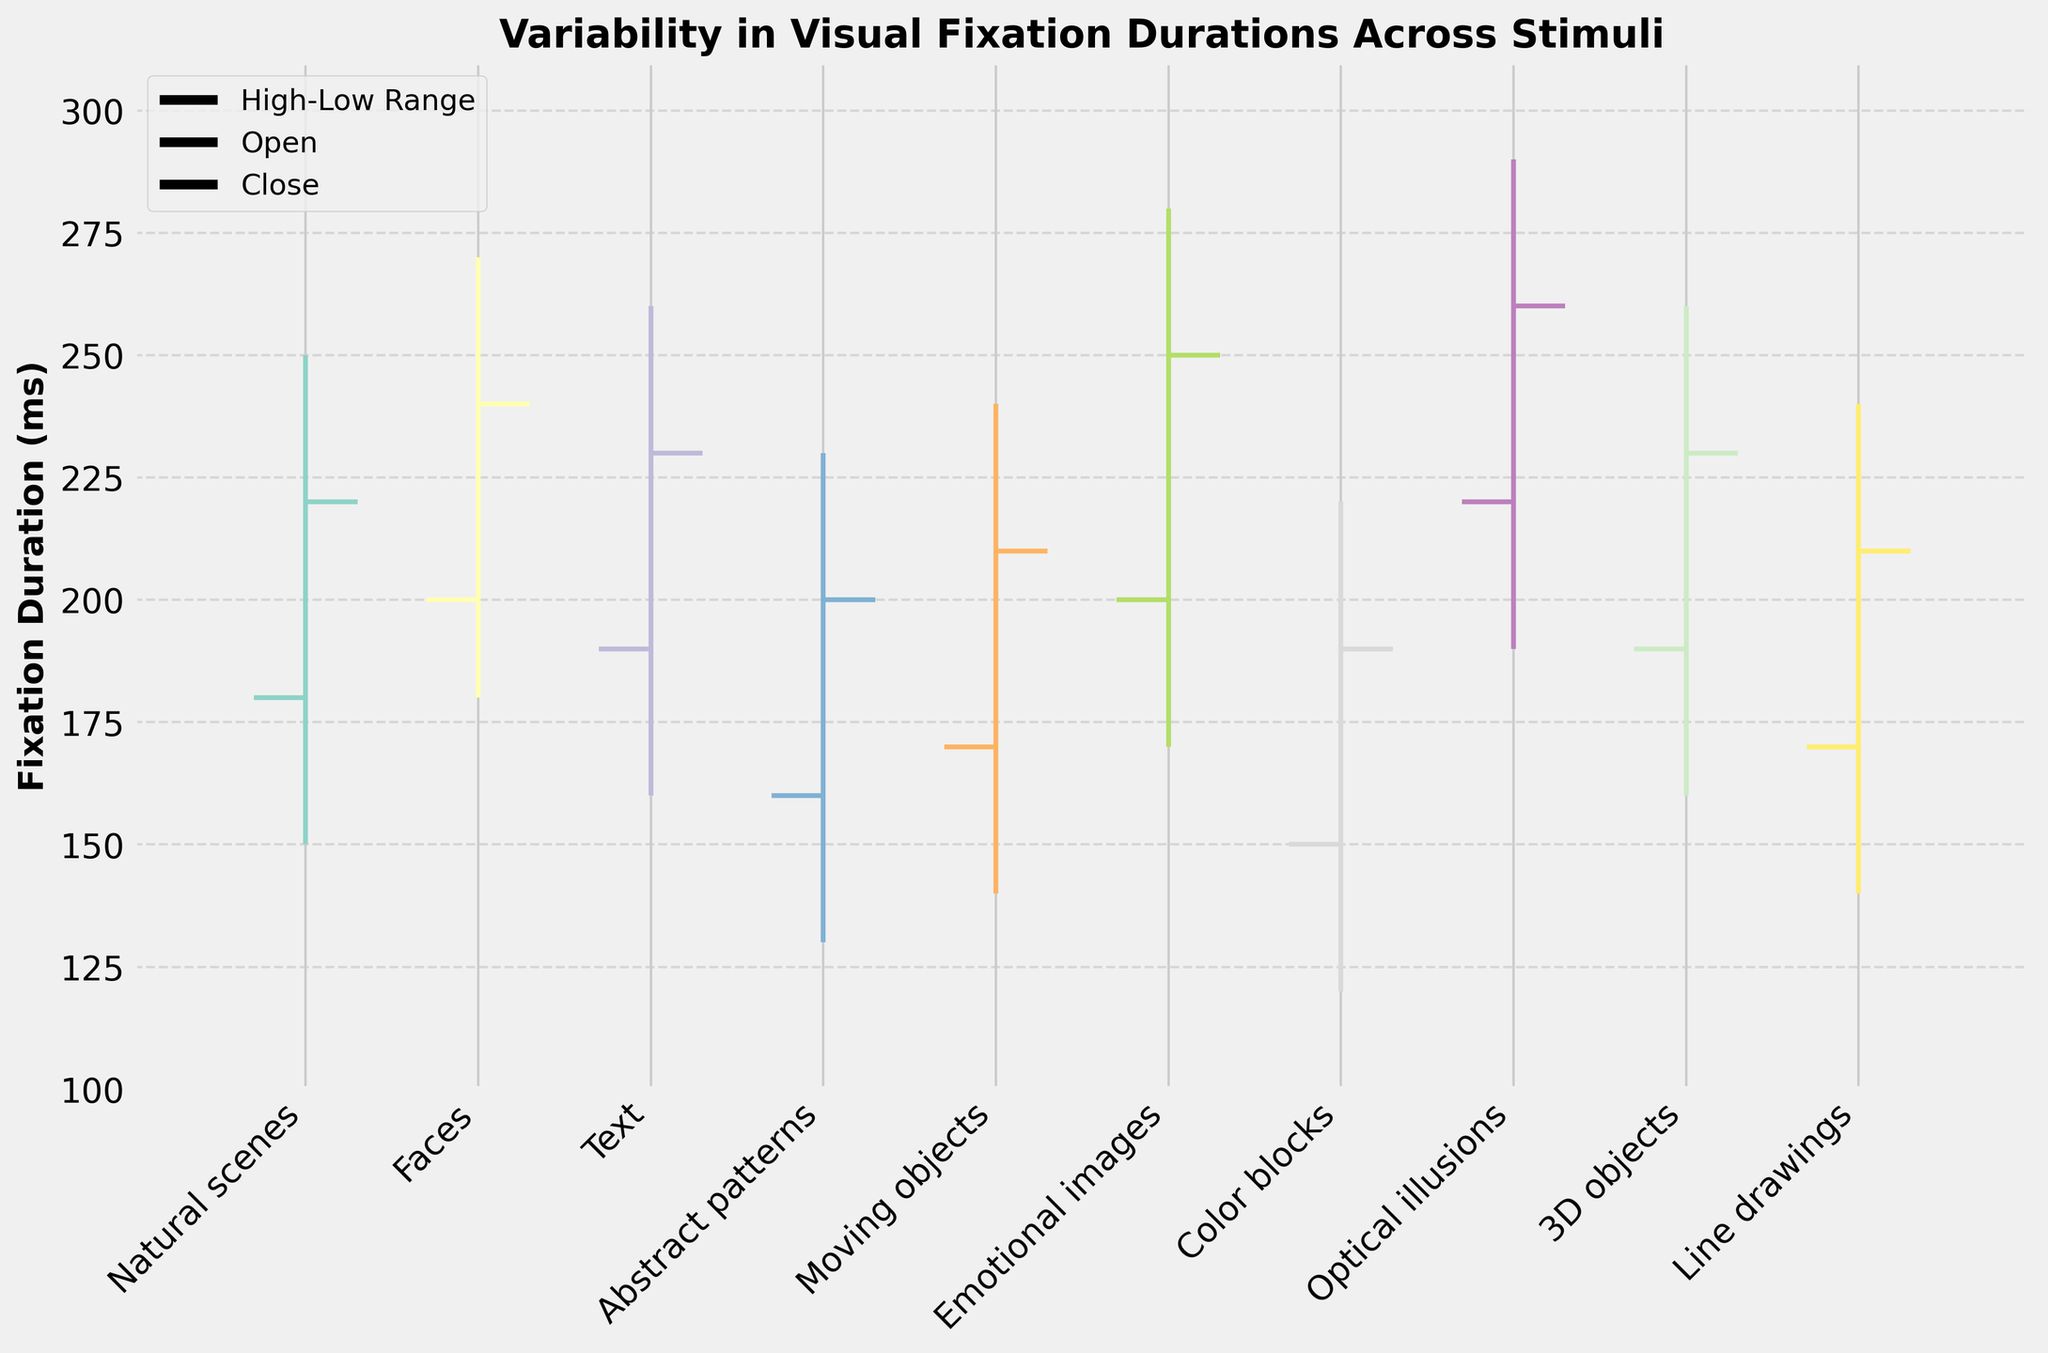what is the title of the plot? The title of the plot is usually placed at the top of the figure and summarizes the main focus of the chart. Here, the title "Variability in Visual Fixation Durations Across Stimuli" is clearly displayed at the top center.
Answer: Variability in Visual Fixation Durations Across Stimuli what does the y-axis represent? The y-axis label is "Fixation Duration (ms)", which means it represents the duration of visual fixation in milliseconds.
Answer: Fixation Duration (ms) which stimulus has the highest high value for fixation duration? To find the stimulus with the highest high value, check the topmost point of each vertical line. The "Optical illusions" stimulus reaches the highest point at 290 ms.
Answer: Optical illusions which stimulus has the lowest low value for fixation duration? The lowest point of each vertical line represents the low value. "Color blocks" has the lowest low value at 120 ms.
Answer: Color blocks how many types of stimuli are represented in the plot? Count the number of distinct labels on the x-axis. There are 10 different stimuli listed.
Answer: 10 what is the range of fixation durations for emotional images? The range is calculated by subtracting the low value from the high value. For "Emotional images", the high value is 280 ms, and the low value is 170 ms. So, 280 - 170 = 110 ms.
Answer: 110 ms what are the open and close fixation durations for faces? For "Faces", the open value is represented by the left tick (200 ms), and the close value is represented by the right tick (240 ms).
Answer: 200 ms (Open), 240 ms (Close) which stimulus has the smallest difference between open and close values? Calculate the difference (absolute value) between open and close values for each stimulus. "Line drawings" has the smallest difference, with open at 170 ms and close at 210 ms, resulting in a difference of 40 ms.
Answer: Line drawings comparing natural scenes and text, which has a higher median fixation duration? The median between open and close is (Open + Close) / 2. For "Natural scenes", median = (180 + 220) / 2 = 200 ms, and for "Text", median = (190 + 230) / 2 = 210 ms. Thus, "Text" has a higher median fixation duration.
Answer: Text 